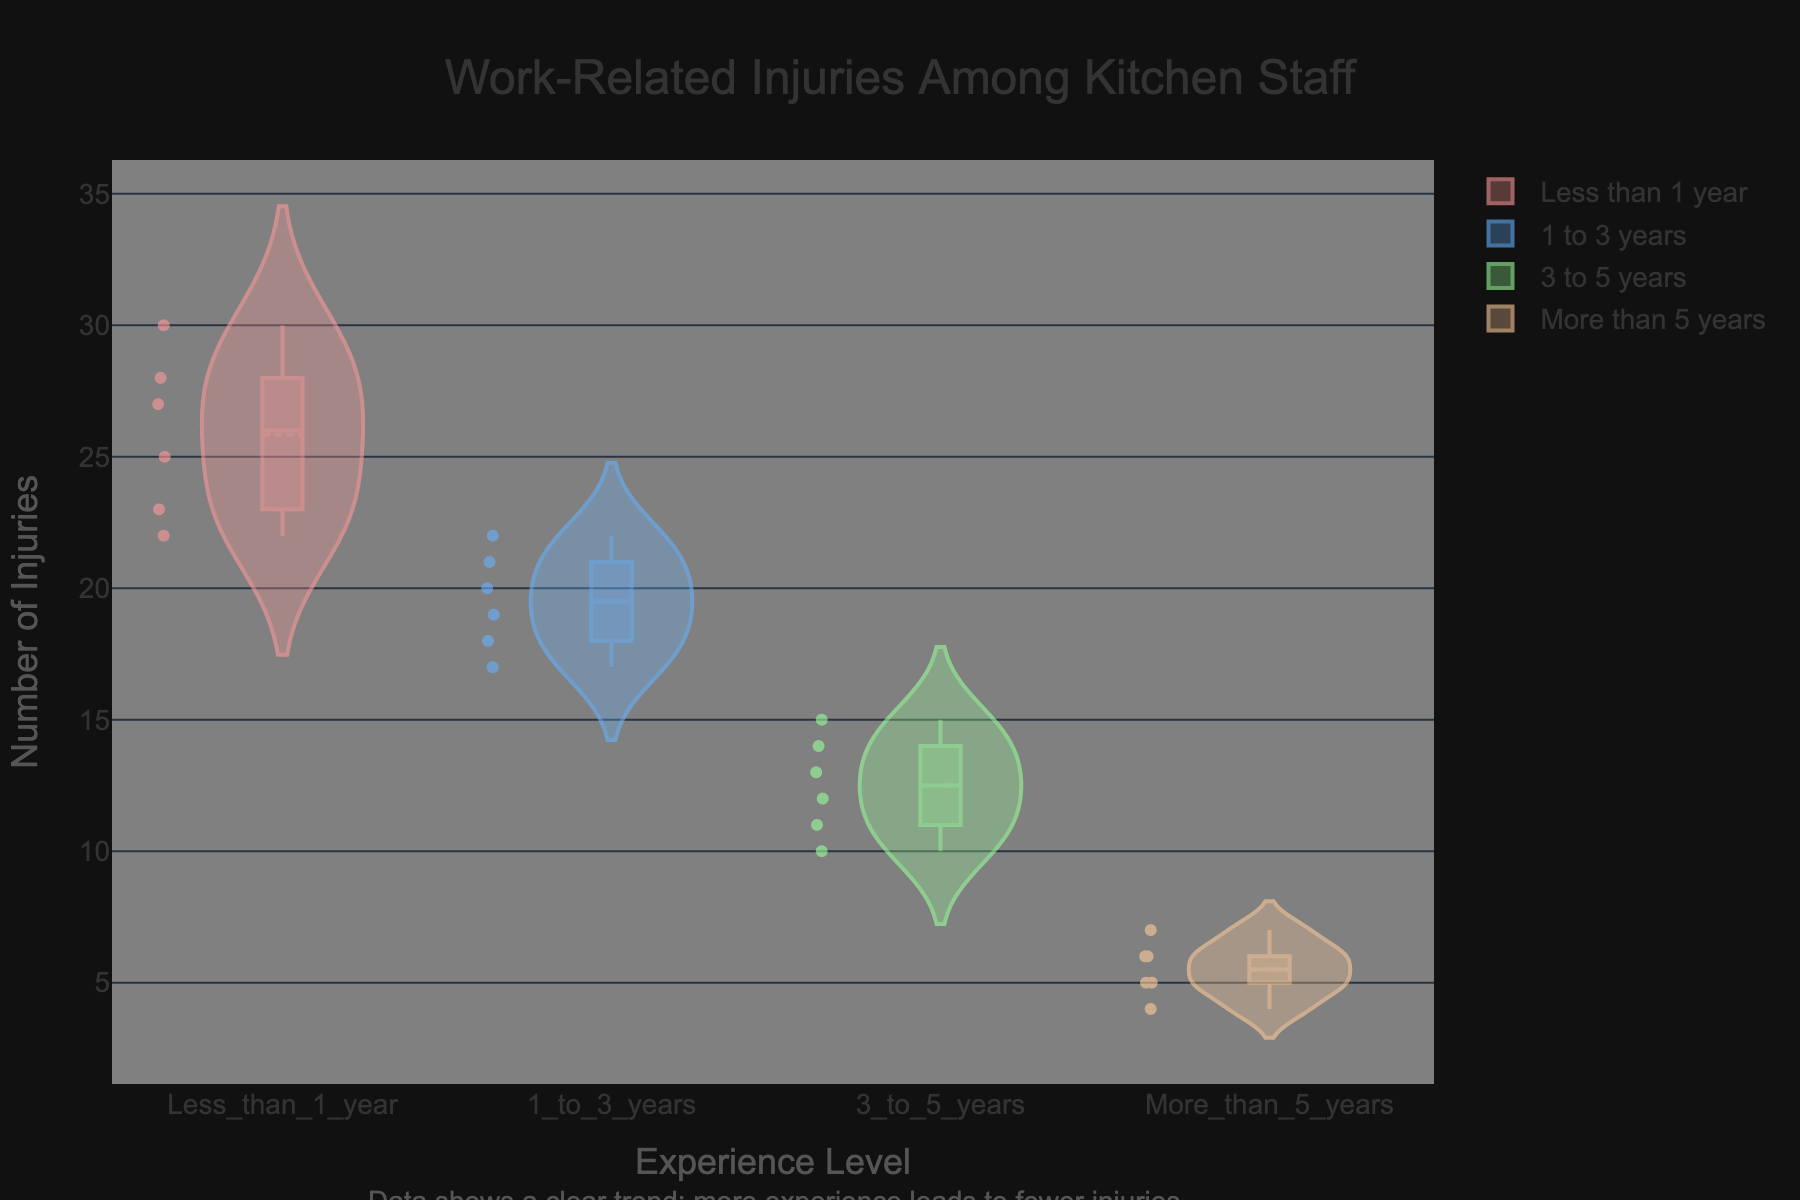What is the title of the chart? The title is usually displayed at the top of the chart. By reading the title, we can understand the main topic or the data that is being visualized.
Answer: Work-Related Injuries Among Kitchen Staff What is the y-axis title? The y-axis title provides information on what is being measured along the vertical axis of the chart. This can usually be read from the left side of the figure.
Answer: Number of Injuries Which experience level has the highest median number of injuries? The median is shown as a line within each box plot that is overlaid on the violin plot. By identifying the highest median line, we can determine which group experiences more frequent injuries on a typical basis.
Answer: Less than 1 year How many experience levels are being compared in the chart? By counting the distinct categories along the x-axis, we can determine the number of experience levels that are included in the analysis.
Answer: 4 What does the annotation at the bottom of the chart indicate about the trend? The annotation usually provides a summary or an insight based on the visualized data. By reading the annotation, we can understand what general trend is being highlighted.
Answer: More experience leads to fewer injuries Which experience level shows the widest distribution of injuries? The width of the violin plot represents the distribution of data. By comparing the widths of the plots for each experience level, we can identify the one with the most spread in its data.
Answer: Less than 1 year What is the average number of injuries for the '1 to 3 years' experience level? By identifying the data points within the '1 to 3 years' group, summing them up (18 + 20 + 21 + 19 + 17 + 22), and then dividing by the number of data points (6), we can find the average.
Answer: 19.5 Which experience level has the smallest interquartile range (IQR) in their box plot? The IQR is the range between the first (lower) and third (upper) quartiles of the box plot. By comparing the height of the boxes across the experience levels, we can determine the smallest IQR.
Answer: More than 5 years What is the maximum number of injuries reported for the '3 to 5 years' experience level? By looking at the highest point within the '3 to 5 years' violin plot, we can determine the maximum number of injuries recorded in that group.
Answer: 15 How does the number of injuries compare between 'Less than 1 year' and 'More than 5 years' experience? By examining the overall shape and range of the violin plots for these two categories, we can compare their distributions and overall number of injuries. 'Less than 1 year' has a much wider distribution and higher number of injuries compared to 'More than 5 years'.
Answer: 'Less than 1 year' has more injuries than 'More than 5 years' 